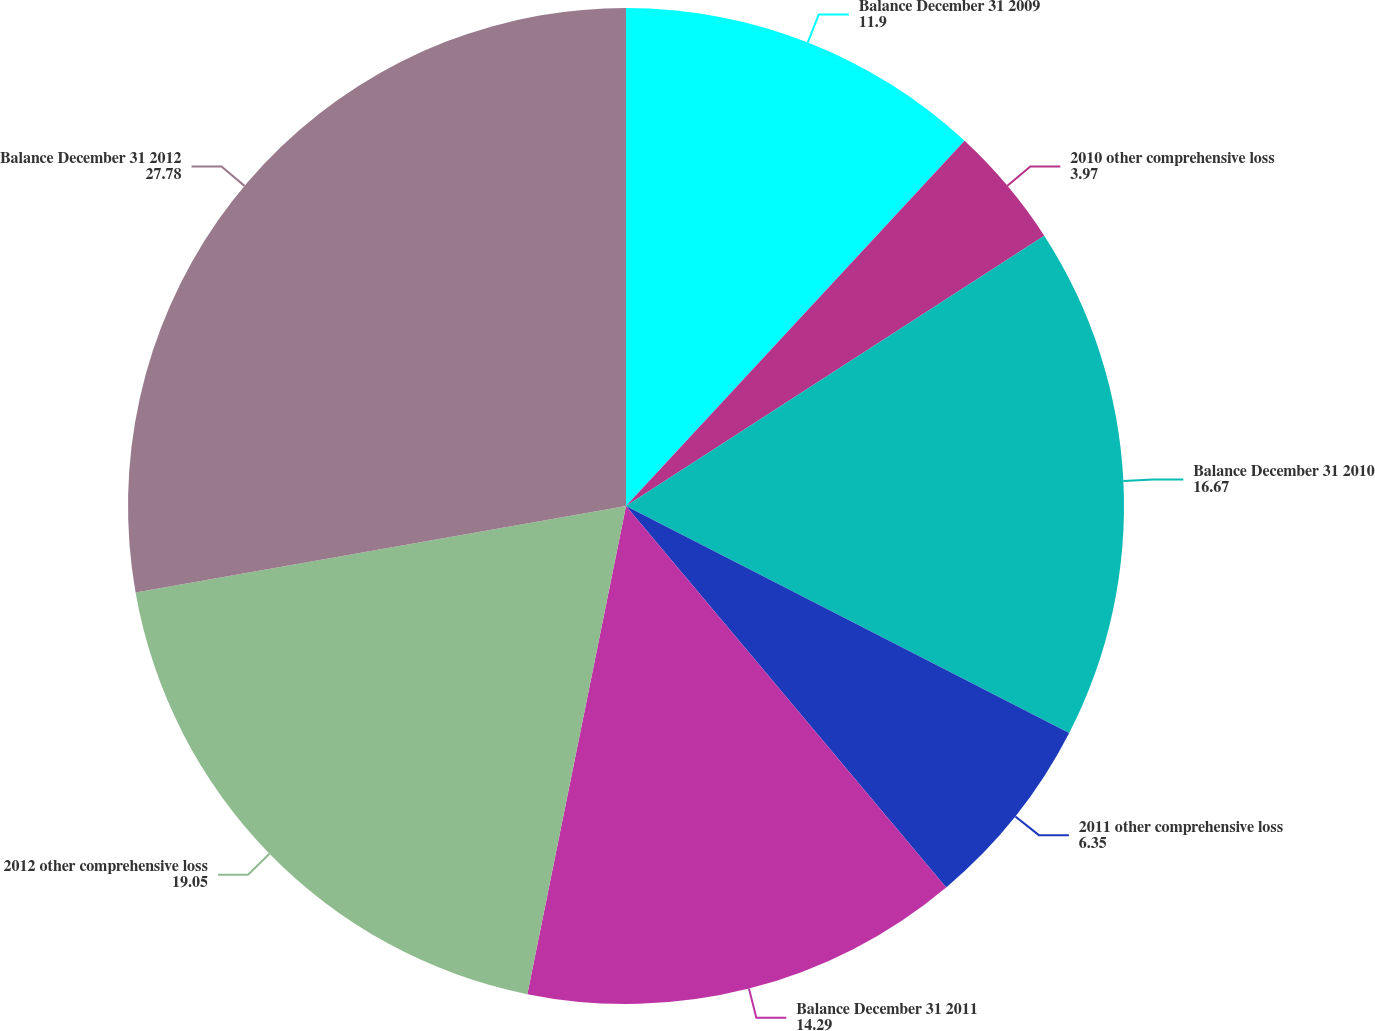Convert chart to OTSL. <chart><loc_0><loc_0><loc_500><loc_500><pie_chart><fcel>Balance December 31 2009<fcel>2010 other comprehensive loss<fcel>Balance December 31 2010<fcel>2011 other comprehensive loss<fcel>Balance December 31 2011<fcel>2012 other comprehensive loss<fcel>Balance December 31 2012<nl><fcel>11.9%<fcel>3.97%<fcel>16.67%<fcel>6.35%<fcel>14.29%<fcel>19.05%<fcel>27.78%<nl></chart> 